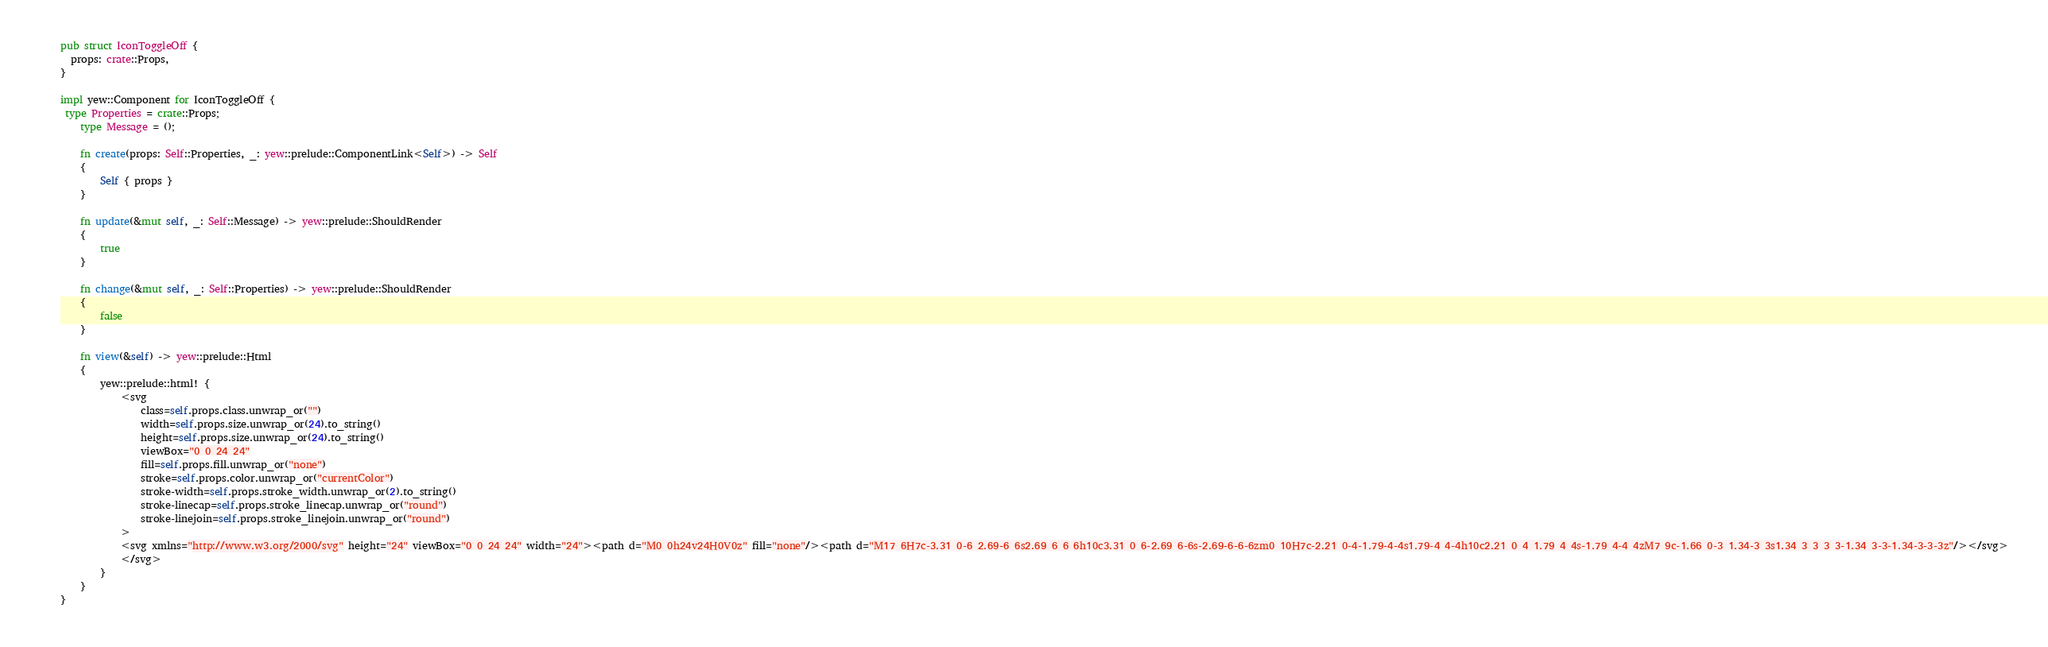<code> <loc_0><loc_0><loc_500><loc_500><_Rust_>
pub struct IconToggleOff {
  props: crate::Props,
}

impl yew::Component for IconToggleOff {
 type Properties = crate::Props;
    type Message = ();

    fn create(props: Self::Properties, _: yew::prelude::ComponentLink<Self>) -> Self
    {
        Self { props }
    }

    fn update(&mut self, _: Self::Message) -> yew::prelude::ShouldRender
    {
        true
    }

    fn change(&mut self, _: Self::Properties) -> yew::prelude::ShouldRender
    {
        false
    }

    fn view(&self) -> yew::prelude::Html
    {
        yew::prelude::html! {
            <svg
                class=self.props.class.unwrap_or("")
                width=self.props.size.unwrap_or(24).to_string()
                height=self.props.size.unwrap_or(24).to_string()
                viewBox="0 0 24 24"
                fill=self.props.fill.unwrap_or("none")
                stroke=self.props.color.unwrap_or("currentColor")
                stroke-width=self.props.stroke_width.unwrap_or(2).to_string()
                stroke-linecap=self.props.stroke_linecap.unwrap_or("round")
                stroke-linejoin=self.props.stroke_linejoin.unwrap_or("round")
            >
            <svg xmlns="http://www.w3.org/2000/svg" height="24" viewBox="0 0 24 24" width="24"><path d="M0 0h24v24H0V0z" fill="none"/><path d="M17 6H7c-3.31 0-6 2.69-6 6s2.69 6 6 6h10c3.31 0 6-2.69 6-6s-2.69-6-6-6zm0 10H7c-2.21 0-4-1.79-4-4s1.79-4 4-4h10c2.21 0 4 1.79 4 4s-1.79 4-4 4zM7 9c-1.66 0-3 1.34-3 3s1.34 3 3 3 3-1.34 3-3-1.34-3-3-3z"/></svg>
            </svg>
        }
    }
}


</code> 